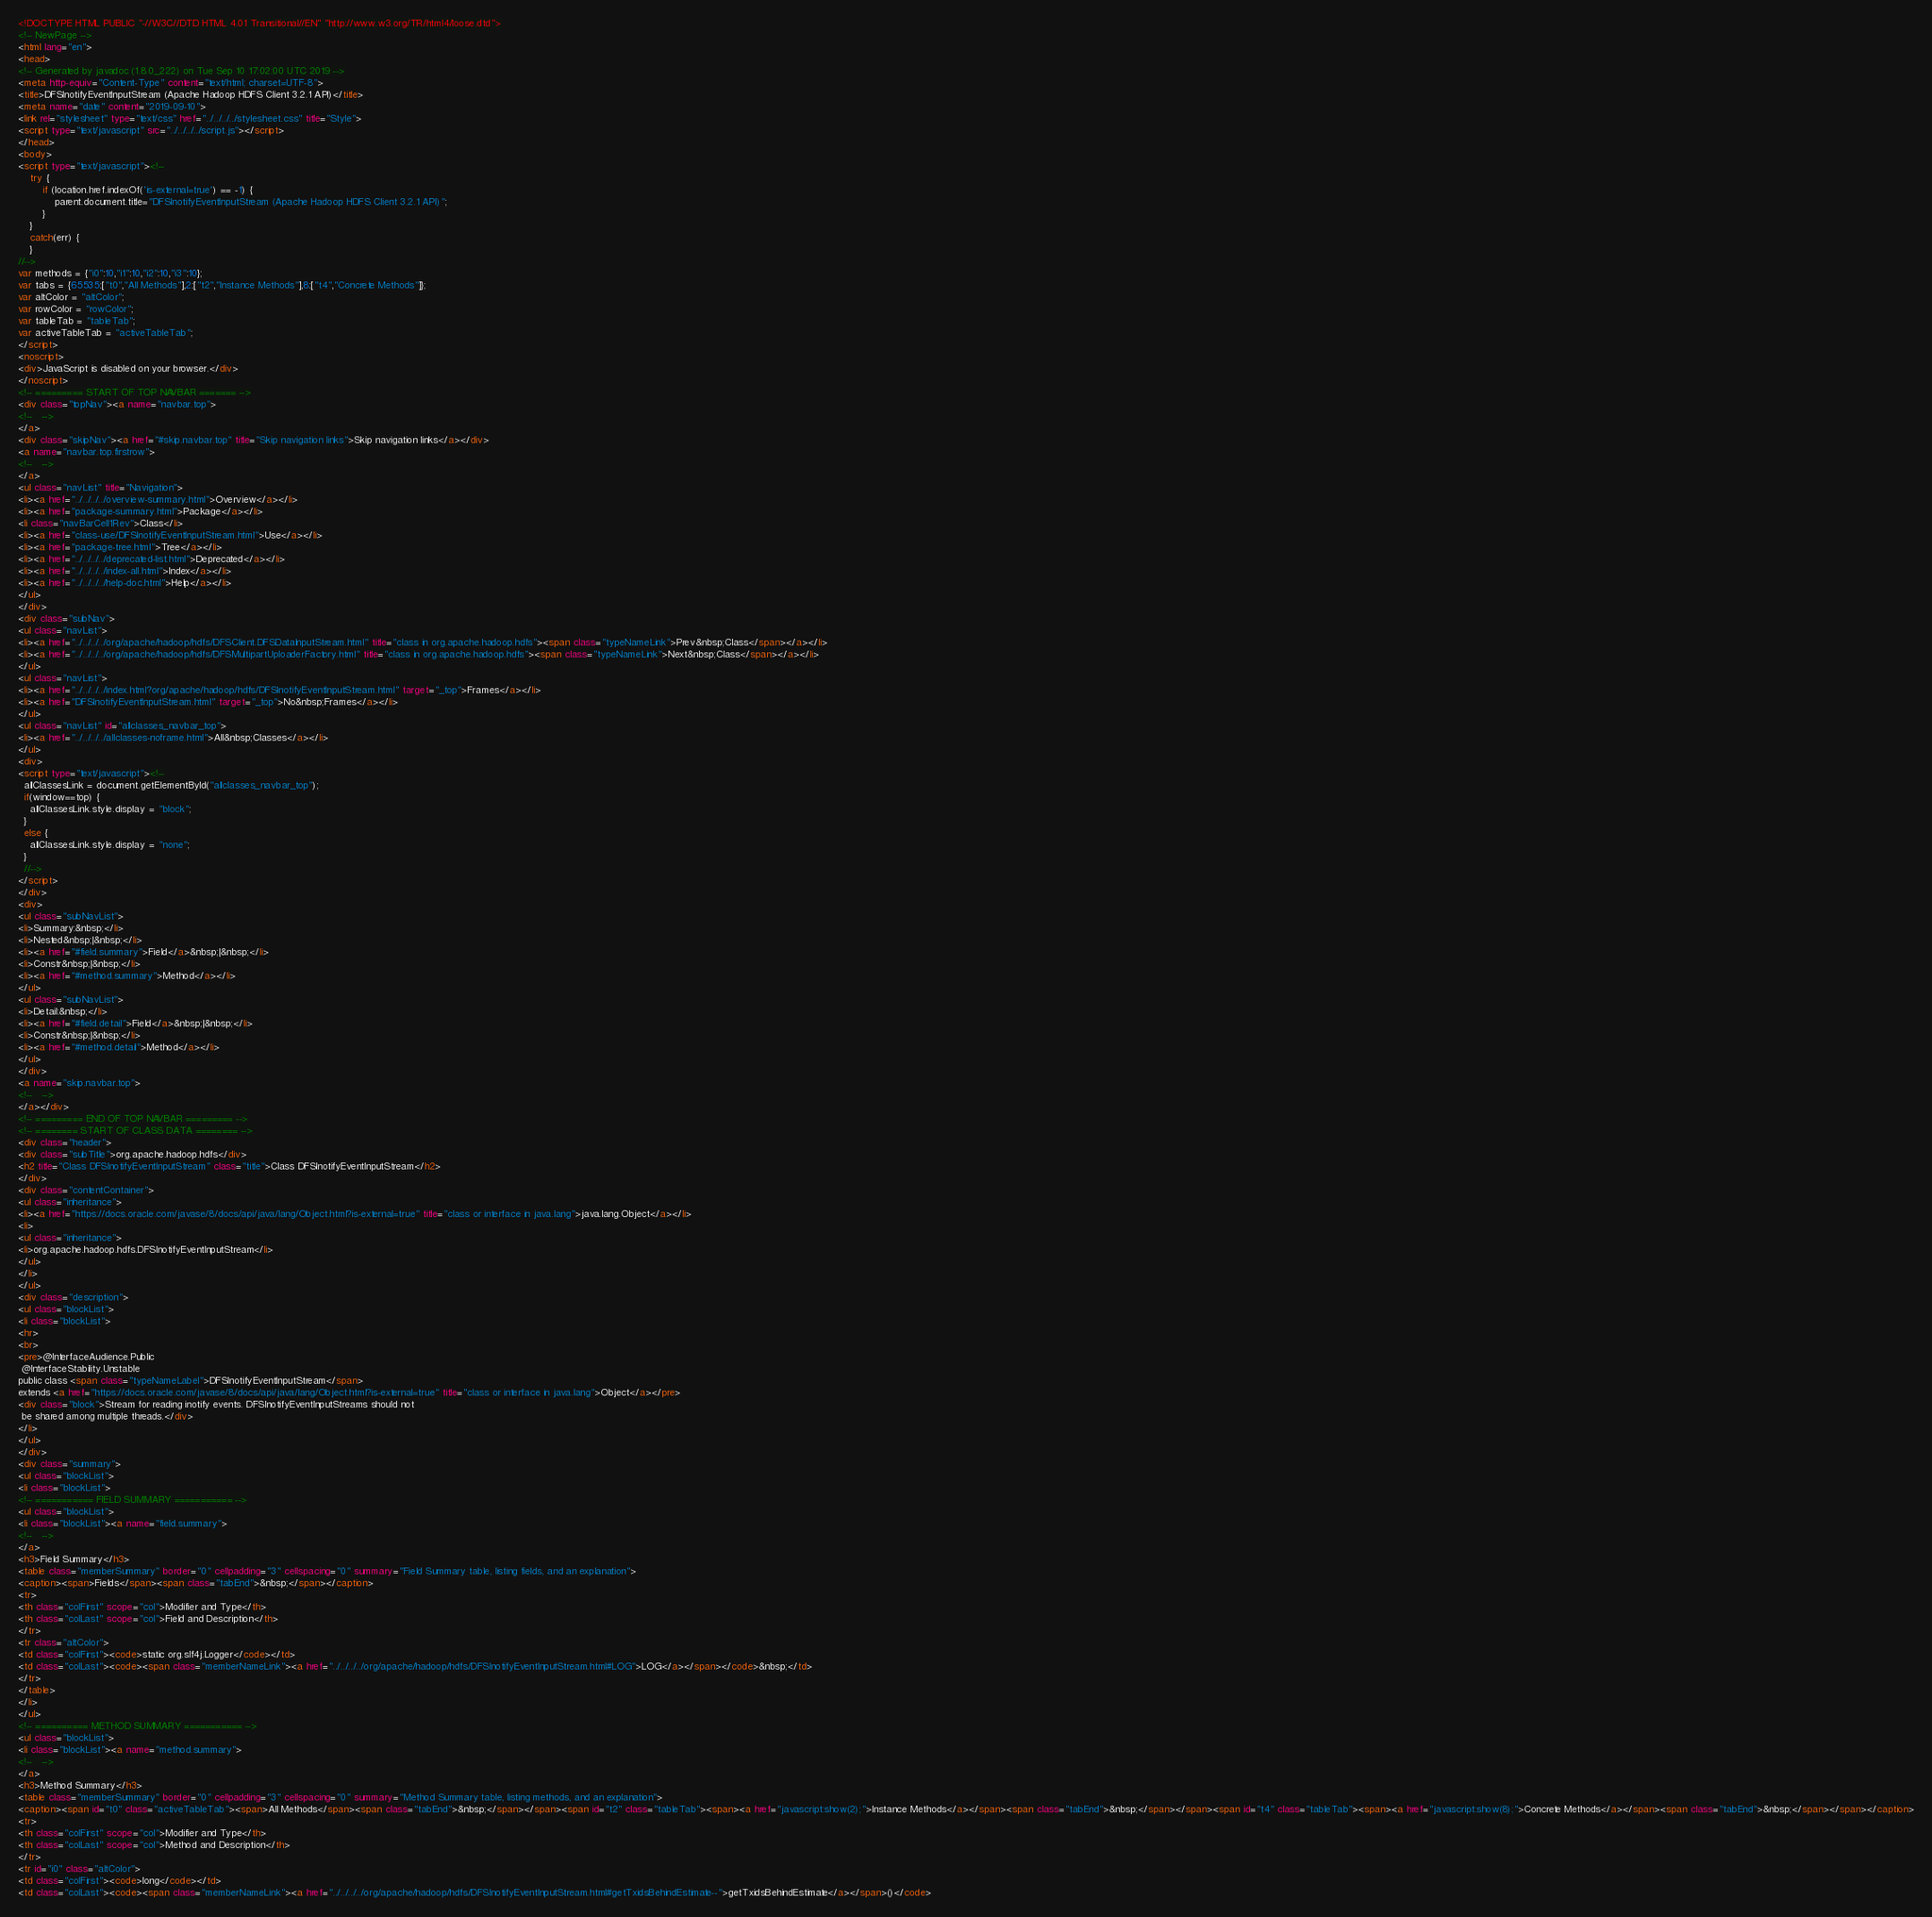<code> <loc_0><loc_0><loc_500><loc_500><_HTML_><!DOCTYPE HTML PUBLIC "-//W3C//DTD HTML 4.01 Transitional//EN" "http://www.w3.org/TR/html4/loose.dtd">
<!-- NewPage -->
<html lang="en">
<head>
<!-- Generated by javadoc (1.8.0_222) on Tue Sep 10 17:02:00 UTC 2019 -->
<meta http-equiv="Content-Type" content="text/html; charset=UTF-8">
<title>DFSInotifyEventInputStream (Apache Hadoop HDFS Client 3.2.1 API)</title>
<meta name="date" content="2019-09-10">
<link rel="stylesheet" type="text/css" href="../../../../stylesheet.css" title="Style">
<script type="text/javascript" src="../../../../script.js"></script>
</head>
<body>
<script type="text/javascript"><!--
    try {
        if (location.href.indexOf('is-external=true') == -1) {
            parent.document.title="DFSInotifyEventInputStream (Apache Hadoop HDFS Client 3.2.1 API)";
        }
    }
    catch(err) {
    }
//-->
var methods = {"i0":10,"i1":10,"i2":10,"i3":10};
var tabs = {65535:["t0","All Methods"],2:["t2","Instance Methods"],8:["t4","Concrete Methods"]};
var altColor = "altColor";
var rowColor = "rowColor";
var tableTab = "tableTab";
var activeTableTab = "activeTableTab";
</script>
<noscript>
<div>JavaScript is disabled on your browser.</div>
</noscript>
<!-- ========= START OF TOP NAVBAR ======= -->
<div class="topNav"><a name="navbar.top">
<!--   -->
</a>
<div class="skipNav"><a href="#skip.navbar.top" title="Skip navigation links">Skip navigation links</a></div>
<a name="navbar.top.firstrow">
<!--   -->
</a>
<ul class="navList" title="Navigation">
<li><a href="../../../../overview-summary.html">Overview</a></li>
<li><a href="package-summary.html">Package</a></li>
<li class="navBarCell1Rev">Class</li>
<li><a href="class-use/DFSInotifyEventInputStream.html">Use</a></li>
<li><a href="package-tree.html">Tree</a></li>
<li><a href="../../../../deprecated-list.html">Deprecated</a></li>
<li><a href="../../../../index-all.html">Index</a></li>
<li><a href="../../../../help-doc.html">Help</a></li>
</ul>
</div>
<div class="subNav">
<ul class="navList">
<li><a href="../../../../org/apache/hadoop/hdfs/DFSClient.DFSDataInputStream.html" title="class in org.apache.hadoop.hdfs"><span class="typeNameLink">Prev&nbsp;Class</span></a></li>
<li><a href="../../../../org/apache/hadoop/hdfs/DFSMultipartUploaderFactory.html" title="class in org.apache.hadoop.hdfs"><span class="typeNameLink">Next&nbsp;Class</span></a></li>
</ul>
<ul class="navList">
<li><a href="../../../../index.html?org/apache/hadoop/hdfs/DFSInotifyEventInputStream.html" target="_top">Frames</a></li>
<li><a href="DFSInotifyEventInputStream.html" target="_top">No&nbsp;Frames</a></li>
</ul>
<ul class="navList" id="allclasses_navbar_top">
<li><a href="../../../../allclasses-noframe.html">All&nbsp;Classes</a></li>
</ul>
<div>
<script type="text/javascript"><!--
  allClassesLink = document.getElementById("allclasses_navbar_top");
  if(window==top) {
    allClassesLink.style.display = "block";
  }
  else {
    allClassesLink.style.display = "none";
  }
  //-->
</script>
</div>
<div>
<ul class="subNavList">
<li>Summary:&nbsp;</li>
<li>Nested&nbsp;|&nbsp;</li>
<li><a href="#field.summary">Field</a>&nbsp;|&nbsp;</li>
<li>Constr&nbsp;|&nbsp;</li>
<li><a href="#method.summary">Method</a></li>
</ul>
<ul class="subNavList">
<li>Detail:&nbsp;</li>
<li><a href="#field.detail">Field</a>&nbsp;|&nbsp;</li>
<li>Constr&nbsp;|&nbsp;</li>
<li><a href="#method.detail">Method</a></li>
</ul>
</div>
<a name="skip.navbar.top">
<!--   -->
</a></div>
<!-- ========= END OF TOP NAVBAR ========= -->
<!-- ======== START OF CLASS DATA ======== -->
<div class="header">
<div class="subTitle">org.apache.hadoop.hdfs</div>
<h2 title="Class DFSInotifyEventInputStream" class="title">Class DFSInotifyEventInputStream</h2>
</div>
<div class="contentContainer">
<ul class="inheritance">
<li><a href="https://docs.oracle.com/javase/8/docs/api/java/lang/Object.html?is-external=true" title="class or interface in java.lang">java.lang.Object</a></li>
<li>
<ul class="inheritance">
<li>org.apache.hadoop.hdfs.DFSInotifyEventInputStream</li>
</ul>
</li>
</ul>
<div class="description">
<ul class="blockList">
<li class="blockList">
<hr>
<br>
<pre>@InterfaceAudience.Public
 @InterfaceStability.Unstable
public class <span class="typeNameLabel">DFSInotifyEventInputStream</span>
extends <a href="https://docs.oracle.com/javase/8/docs/api/java/lang/Object.html?is-external=true" title="class or interface in java.lang">Object</a></pre>
<div class="block">Stream for reading inotify events. DFSInotifyEventInputStreams should not
 be shared among multiple threads.</div>
</li>
</ul>
</div>
<div class="summary">
<ul class="blockList">
<li class="blockList">
<!-- =========== FIELD SUMMARY =========== -->
<ul class="blockList">
<li class="blockList"><a name="field.summary">
<!--   -->
</a>
<h3>Field Summary</h3>
<table class="memberSummary" border="0" cellpadding="3" cellspacing="0" summary="Field Summary table, listing fields, and an explanation">
<caption><span>Fields</span><span class="tabEnd">&nbsp;</span></caption>
<tr>
<th class="colFirst" scope="col">Modifier and Type</th>
<th class="colLast" scope="col">Field and Description</th>
</tr>
<tr class="altColor">
<td class="colFirst"><code>static org.slf4j.Logger</code></td>
<td class="colLast"><code><span class="memberNameLink"><a href="../../../../org/apache/hadoop/hdfs/DFSInotifyEventInputStream.html#LOG">LOG</a></span></code>&nbsp;</td>
</tr>
</table>
</li>
</ul>
<!-- ========== METHOD SUMMARY =========== -->
<ul class="blockList">
<li class="blockList"><a name="method.summary">
<!--   -->
</a>
<h3>Method Summary</h3>
<table class="memberSummary" border="0" cellpadding="3" cellspacing="0" summary="Method Summary table, listing methods, and an explanation">
<caption><span id="t0" class="activeTableTab"><span>All Methods</span><span class="tabEnd">&nbsp;</span></span><span id="t2" class="tableTab"><span><a href="javascript:show(2);">Instance Methods</a></span><span class="tabEnd">&nbsp;</span></span><span id="t4" class="tableTab"><span><a href="javascript:show(8);">Concrete Methods</a></span><span class="tabEnd">&nbsp;</span></span></caption>
<tr>
<th class="colFirst" scope="col">Modifier and Type</th>
<th class="colLast" scope="col">Method and Description</th>
</tr>
<tr id="i0" class="altColor">
<td class="colFirst"><code>long</code></td>
<td class="colLast"><code><span class="memberNameLink"><a href="../../../../org/apache/hadoop/hdfs/DFSInotifyEventInputStream.html#getTxidsBehindEstimate--">getTxidsBehindEstimate</a></span>()</code></code> 